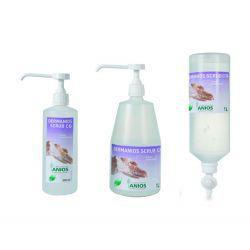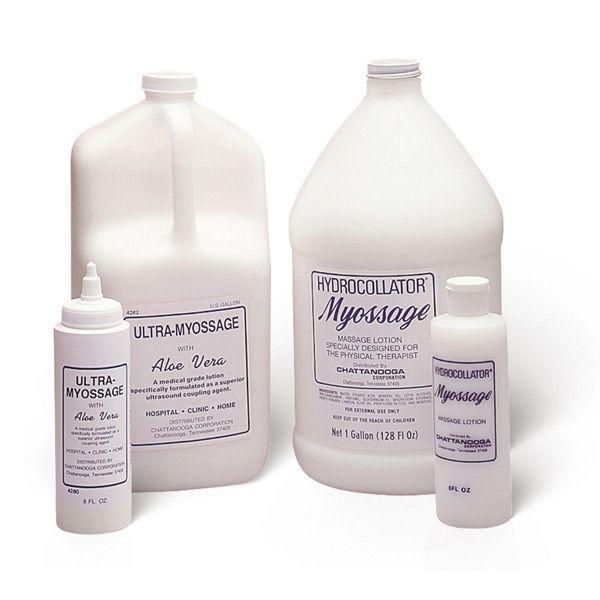The first image is the image on the left, the second image is the image on the right. For the images displayed, is the sentence "At least one image only has one bottle." factually correct? Answer yes or no. No. 